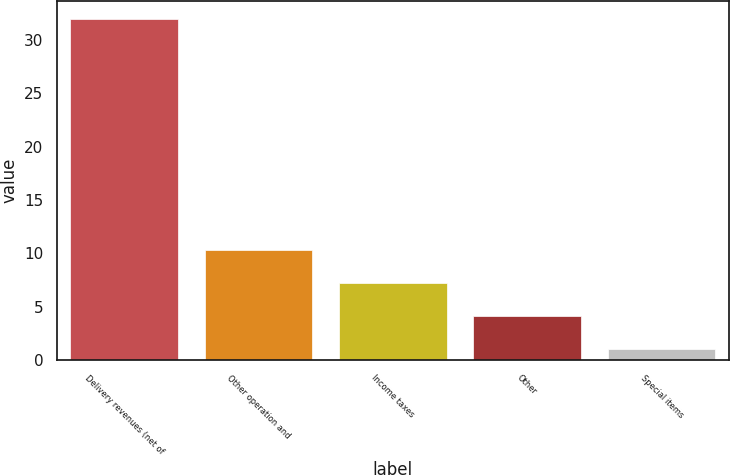Convert chart to OTSL. <chart><loc_0><loc_0><loc_500><loc_500><bar_chart><fcel>Delivery revenues (net of<fcel>Other operation and<fcel>Income taxes<fcel>Other<fcel>Special items<nl><fcel>32<fcel>10.3<fcel>7.2<fcel>4.1<fcel>1<nl></chart> 